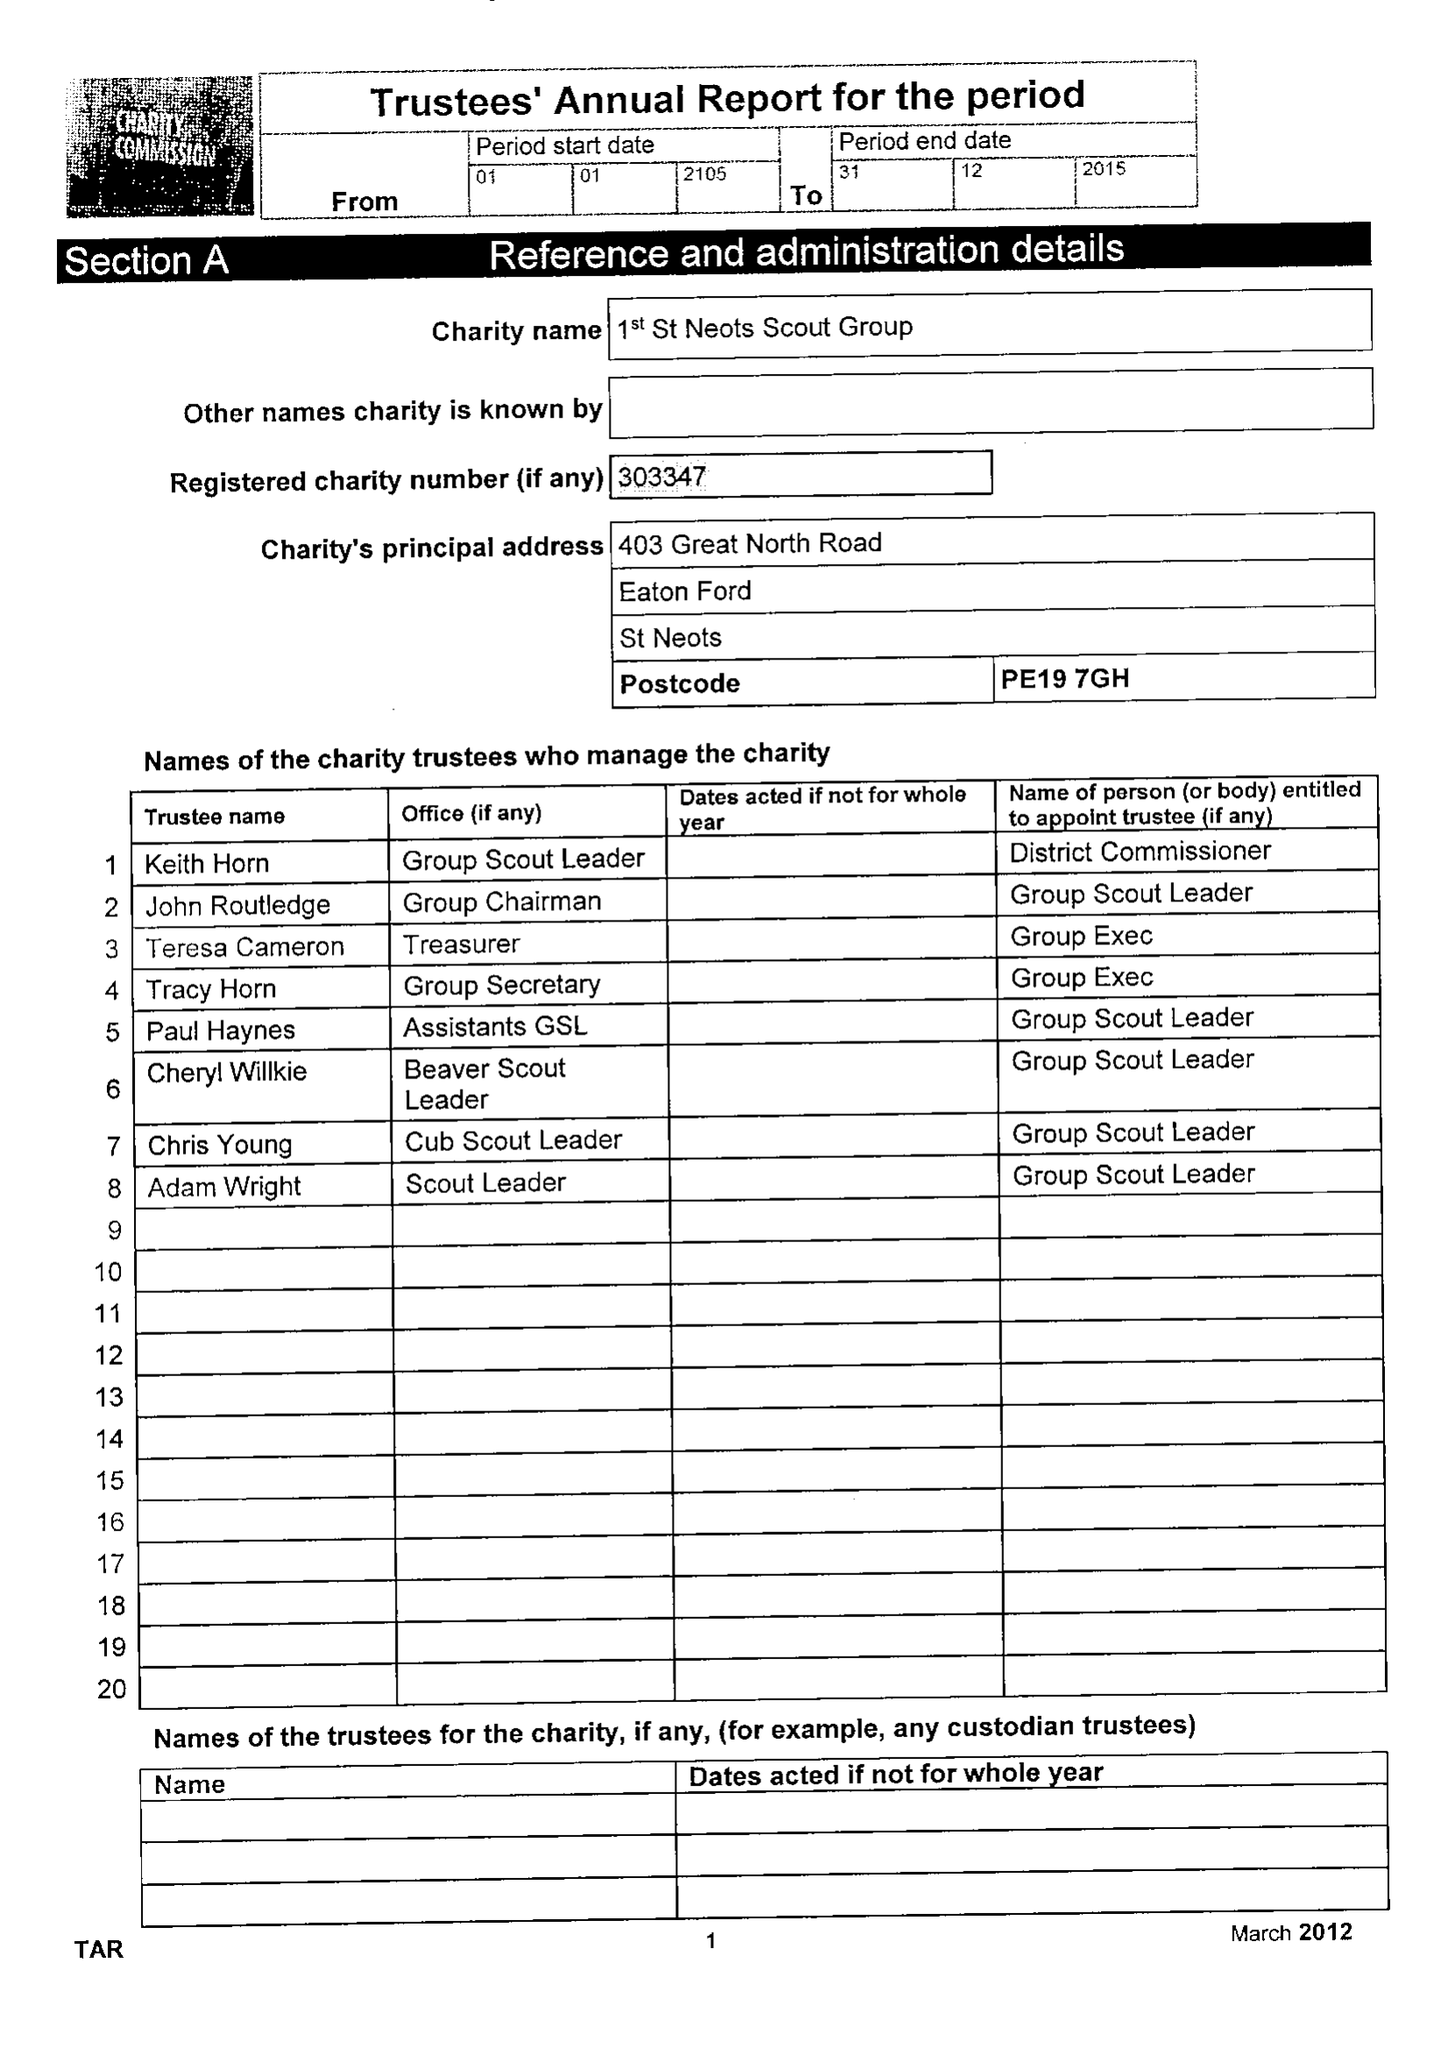What is the value for the address__post_town?
Answer the question using a single word or phrase. ST. NEOTS 